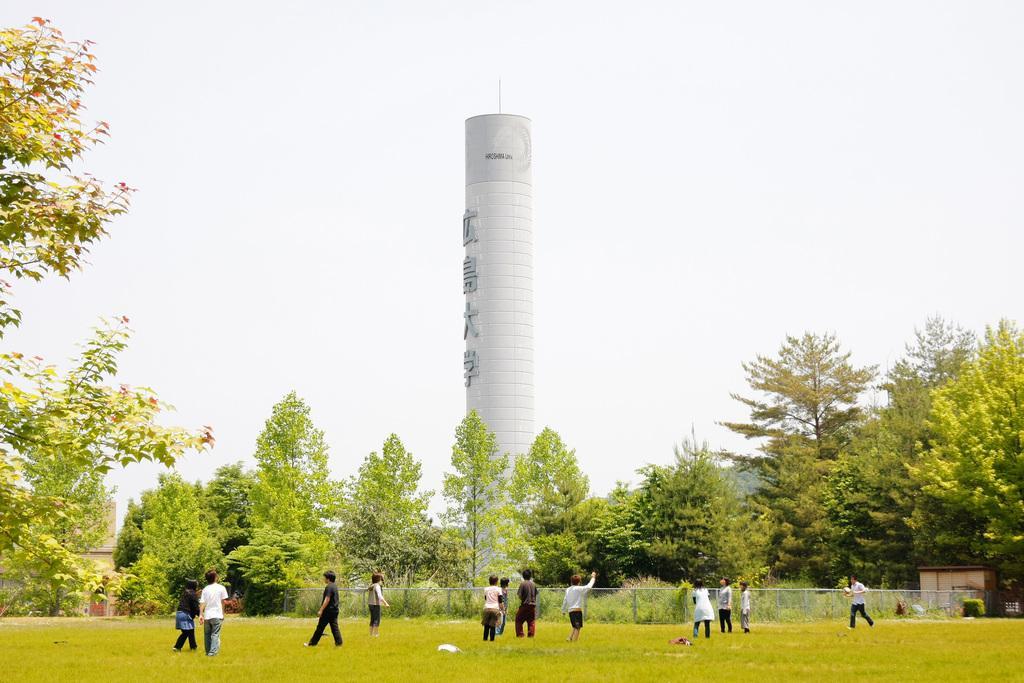In one or two sentences, can you explain what this image depicts? In this image I can see group of people standing. In the background I can see the railing, few trees in green color, the tower and the sky is in white color. 